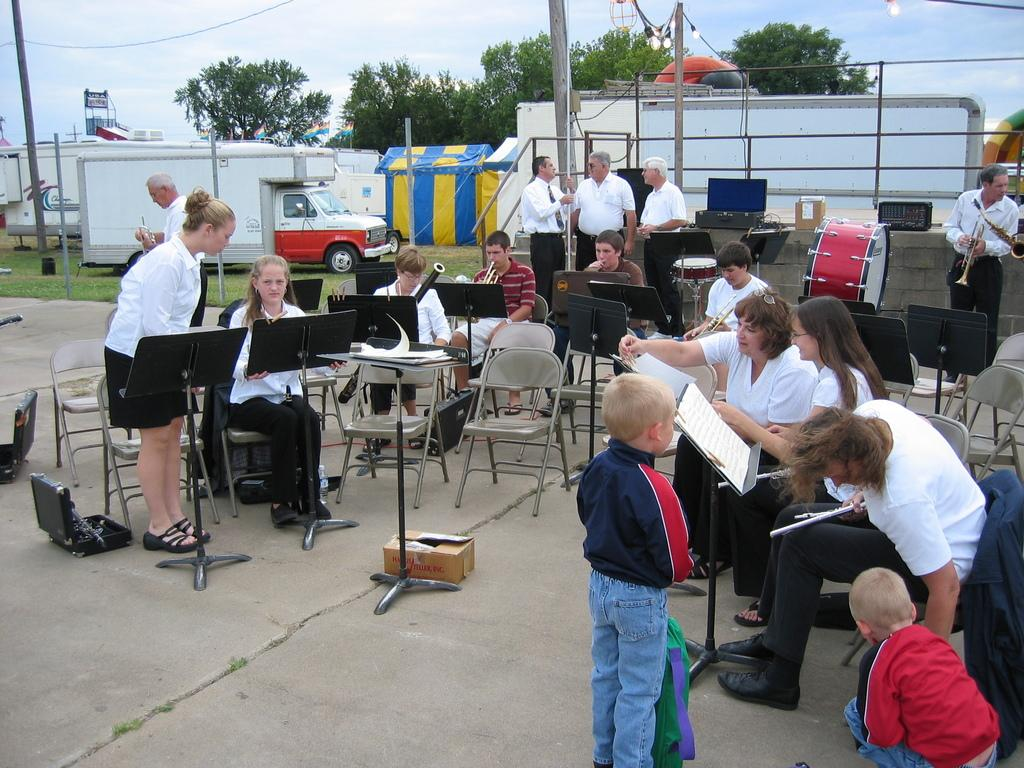What type of furniture can be seen in the image? There are chairs in the image. What else can be seen in the image besides chairs? There are stands, persons, books, musical instruments, a van, tents, trees, sky, and clouds visible in the image. What are the persons in the image doing? The information provided does not specify what the persons are doing. What type of vehicles are present in the image? There is a van in the image. How many quarters can be seen in the image? There are no quarters present in the image. What type of metal is the mind made of in the image? There is no mention of a mind or any metal in the image. 